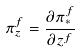<formula> <loc_0><loc_0><loc_500><loc_500>\pi _ { z } ^ { f } = \frac { \partial \pi _ { * } ^ { f } } { \partial z ^ { f } }</formula> 